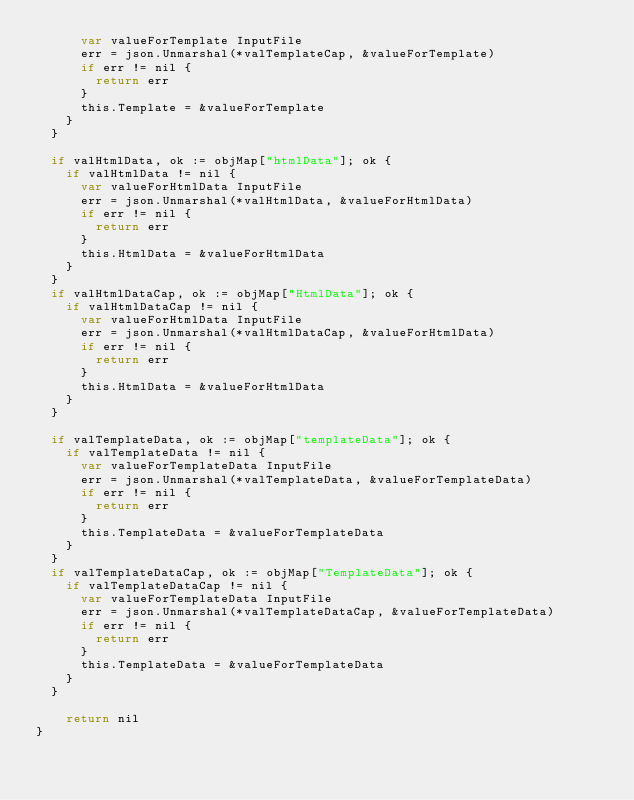Convert code to text. <code><loc_0><loc_0><loc_500><loc_500><_Go_>			var valueForTemplate InputFile
			err = json.Unmarshal(*valTemplateCap, &valueForTemplate)
			if err != nil {
				return err
			}
			this.Template = &valueForTemplate
		}
	}
	
	if valHtmlData, ok := objMap["htmlData"]; ok {
		if valHtmlData != nil {
			var valueForHtmlData InputFile
			err = json.Unmarshal(*valHtmlData, &valueForHtmlData)
			if err != nil {
				return err
			}
			this.HtmlData = &valueForHtmlData
		}
	}
	if valHtmlDataCap, ok := objMap["HtmlData"]; ok {
		if valHtmlDataCap != nil {
			var valueForHtmlData InputFile
			err = json.Unmarshal(*valHtmlDataCap, &valueForHtmlData)
			if err != nil {
				return err
			}
			this.HtmlData = &valueForHtmlData
		}
	}
	
	if valTemplateData, ok := objMap["templateData"]; ok {
		if valTemplateData != nil {
			var valueForTemplateData InputFile
			err = json.Unmarshal(*valTemplateData, &valueForTemplateData)
			if err != nil {
				return err
			}
			this.TemplateData = &valueForTemplateData
		}
	}
	if valTemplateDataCap, ok := objMap["TemplateData"]; ok {
		if valTemplateDataCap != nil {
			var valueForTemplateData InputFile
			err = json.Unmarshal(*valTemplateDataCap, &valueForTemplateData)
			if err != nil {
				return err
			}
			this.TemplateData = &valueForTemplateData
		}
	}

    return nil
}
</code> 